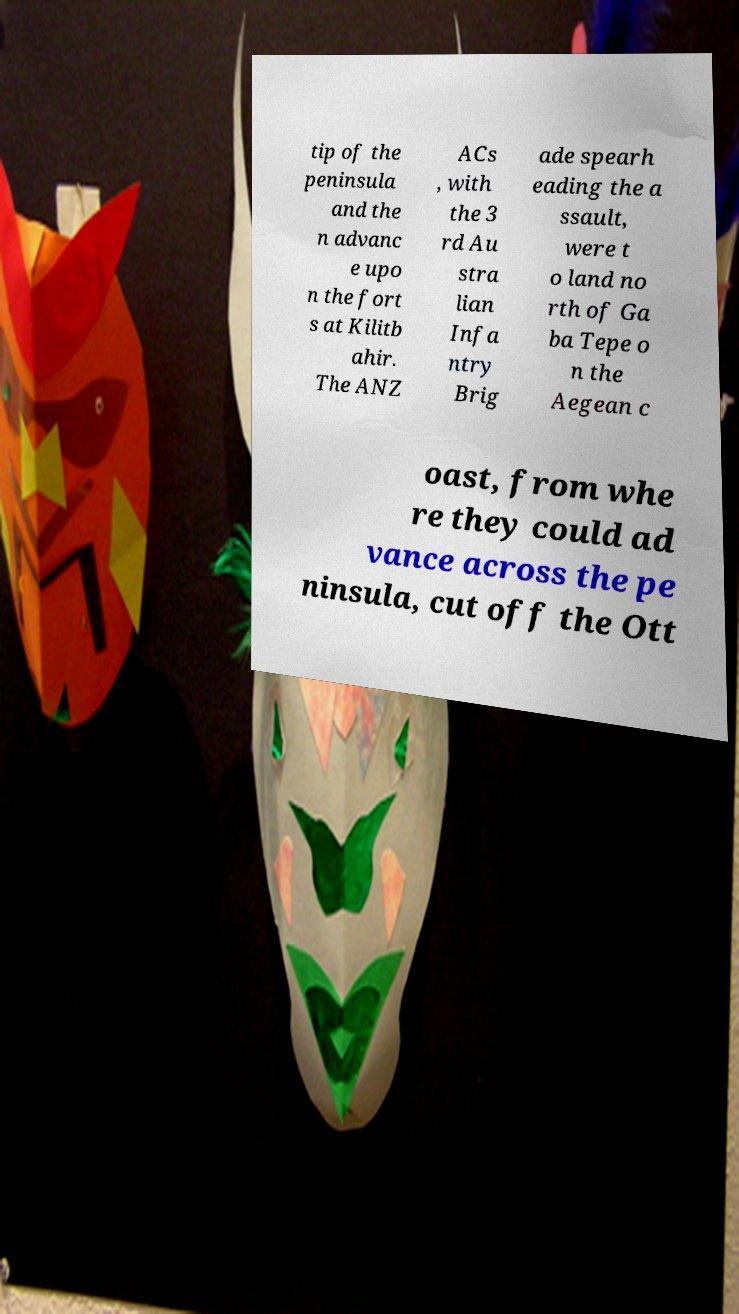Can you accurately transcribe the text from the provided image for me? tip of the peninsula and the n advanc e upo n the fort s at Kilitb ahir. The ANZ ACs , with the 3 rd Au stra lian Infa ntry Brig ade spearh eading the a ssault, were t o land no rth of Ga ba Tepe o n the Aegean c oast, from whe re they could ad vance across the pe ninsula, cut off the Ott 